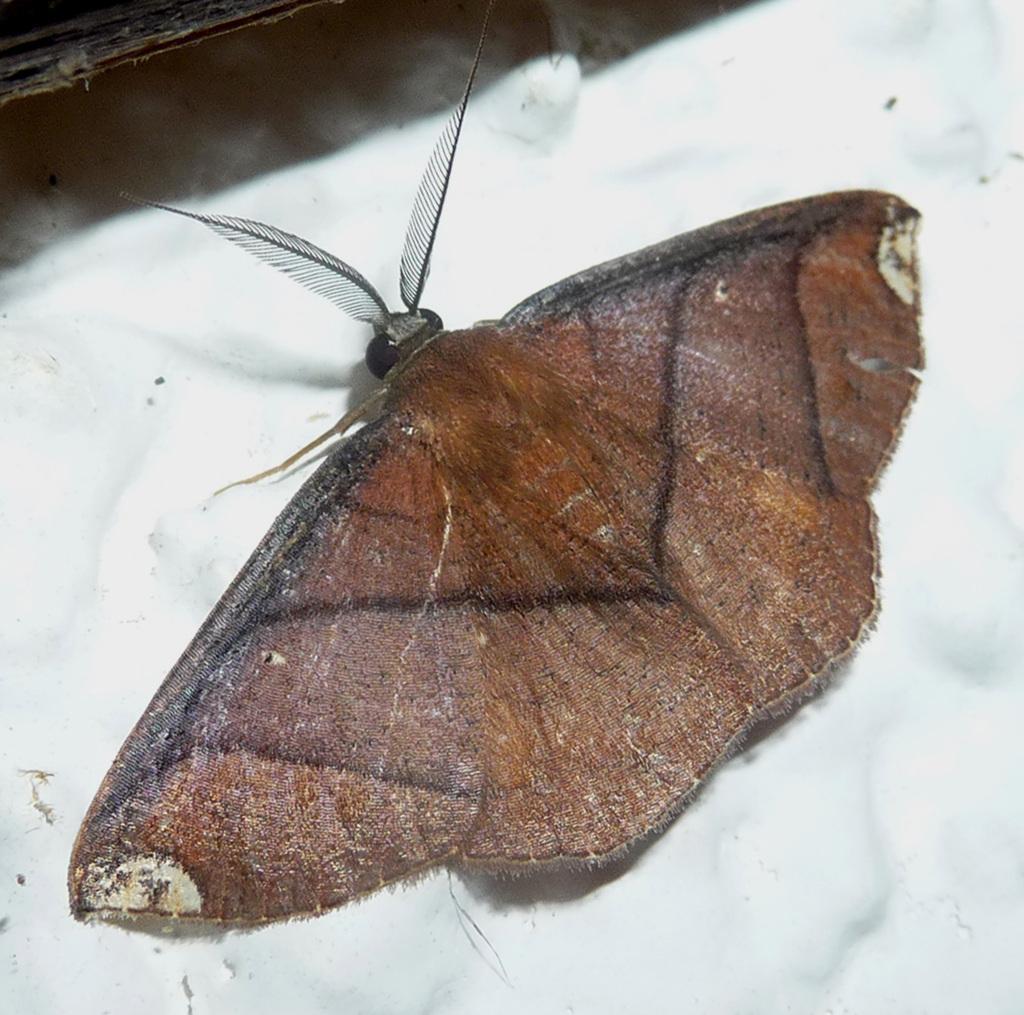Describe this image in one or two sentences. In this image I can see an insect. The background is white in color. 